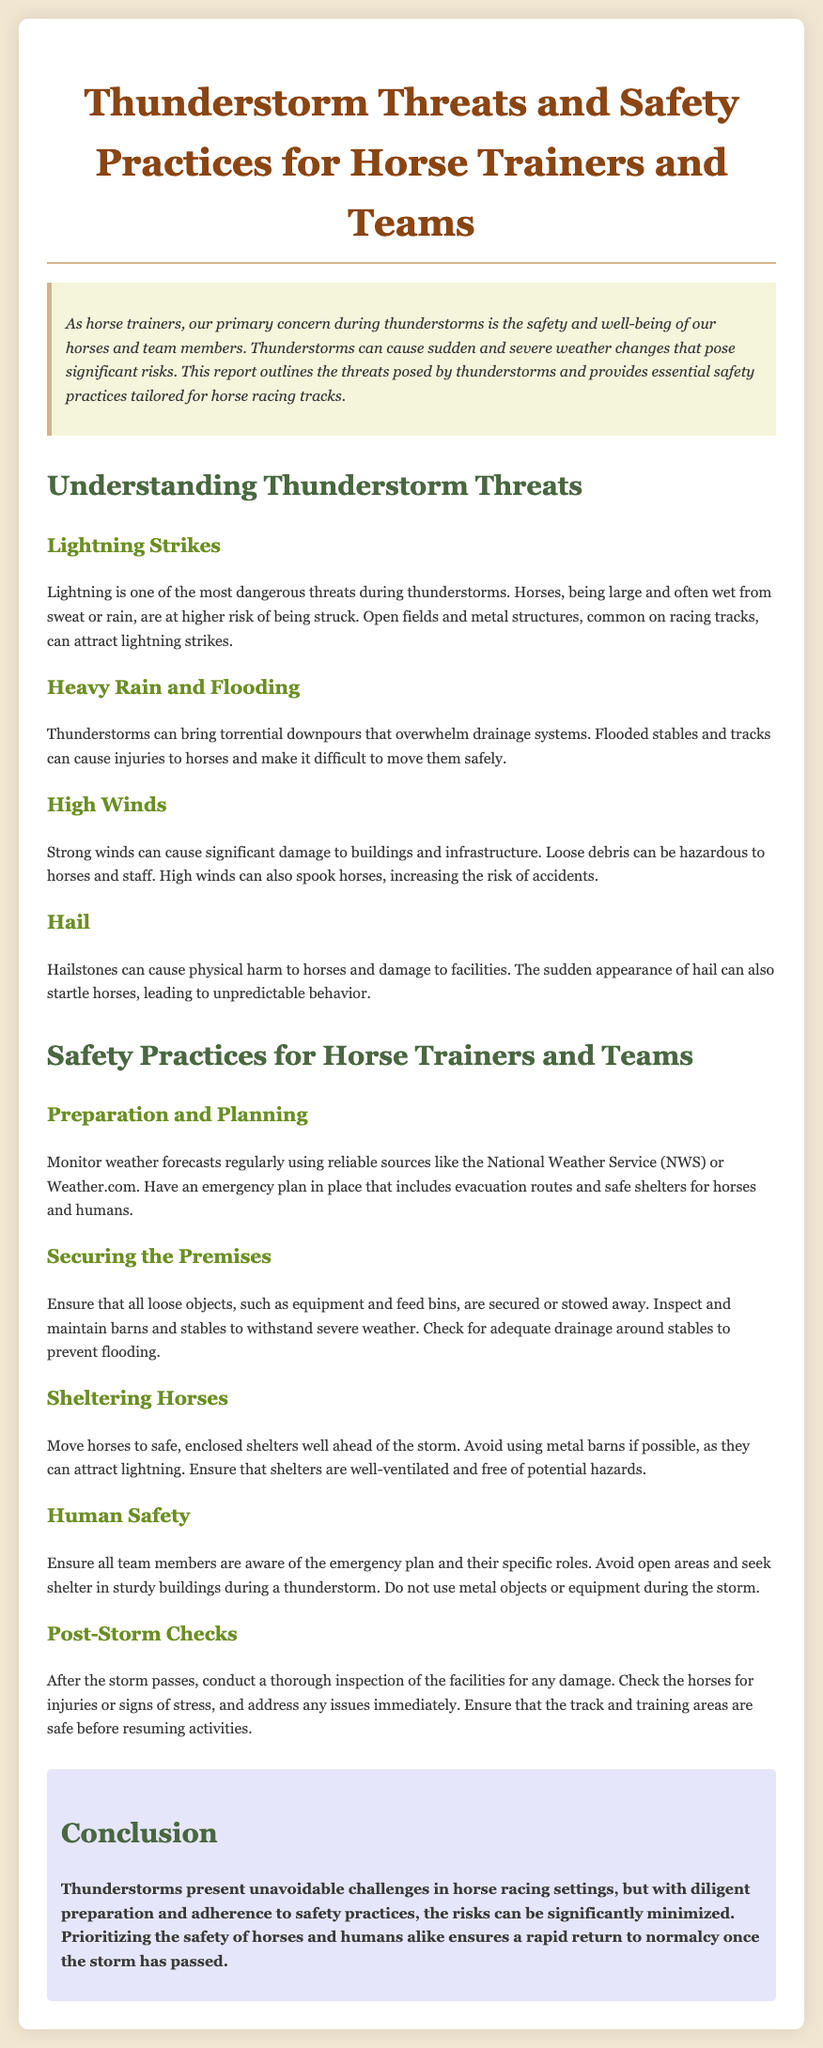what is the main concern during thunderstorms for horse trainers? The main concern is the safety and well-being of horses and team members during thunderstorms.
Answer: safety and well-being what is one of the most dangerous threats during thunderstorms? The document mentions that lightning is one of the most dangerous threats during thunderstorms.
Answer: lightning what should be monitored regularly for thunderstorms? Horse trainers should monitor weather forecasts regularly for thunderstorms.
Answer: weather forecasts what should be secured or stowed away before a storm? All loose objects such as equipment and feed bins should be secured or stowed away.
Answer: loose objects which type of shelter is discouraged due to lightning risks? The document advises avoiding metal barns as they can attract lightning.
Answer: metal barns what should be done after the storm passes? A thorough inspection of the facilities for any damage should be conducted after the storm.
Answer: thorough inspection how should horses be sheltered before a storm? Horses should be moved to safe, enclosed shelters well ahead of the storm.
Answer: safe, enclosed shelters who should be aware of the emergency plan? All team members should be aware of the emergency plan and their specific roles.
Answer: all team members what can high winds cause that is hazardous? High winds can cause loose debris, which can be hazardous to horses and staff.
Answer: loose debris 